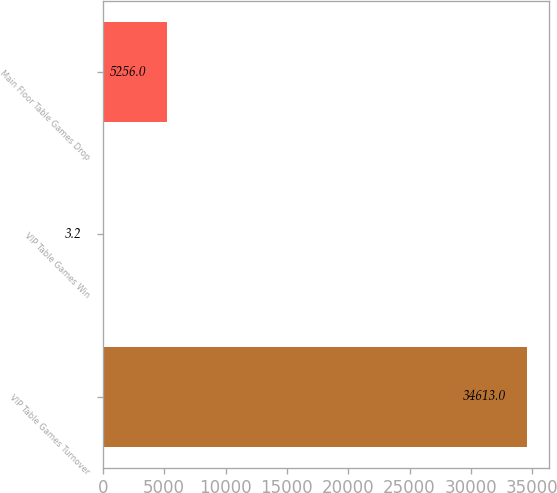Convert chart to OTSL. <chart><loc_0><loc_0><loc_500><loc_500><bar_chart><fcel>VIP Table Games Turnover<fcel>VIP Table Games Win<fcel>Main Floor Table Games Drop<nl><fcel>34613<fcel>3.2<fcel>5256<nl></chart> 